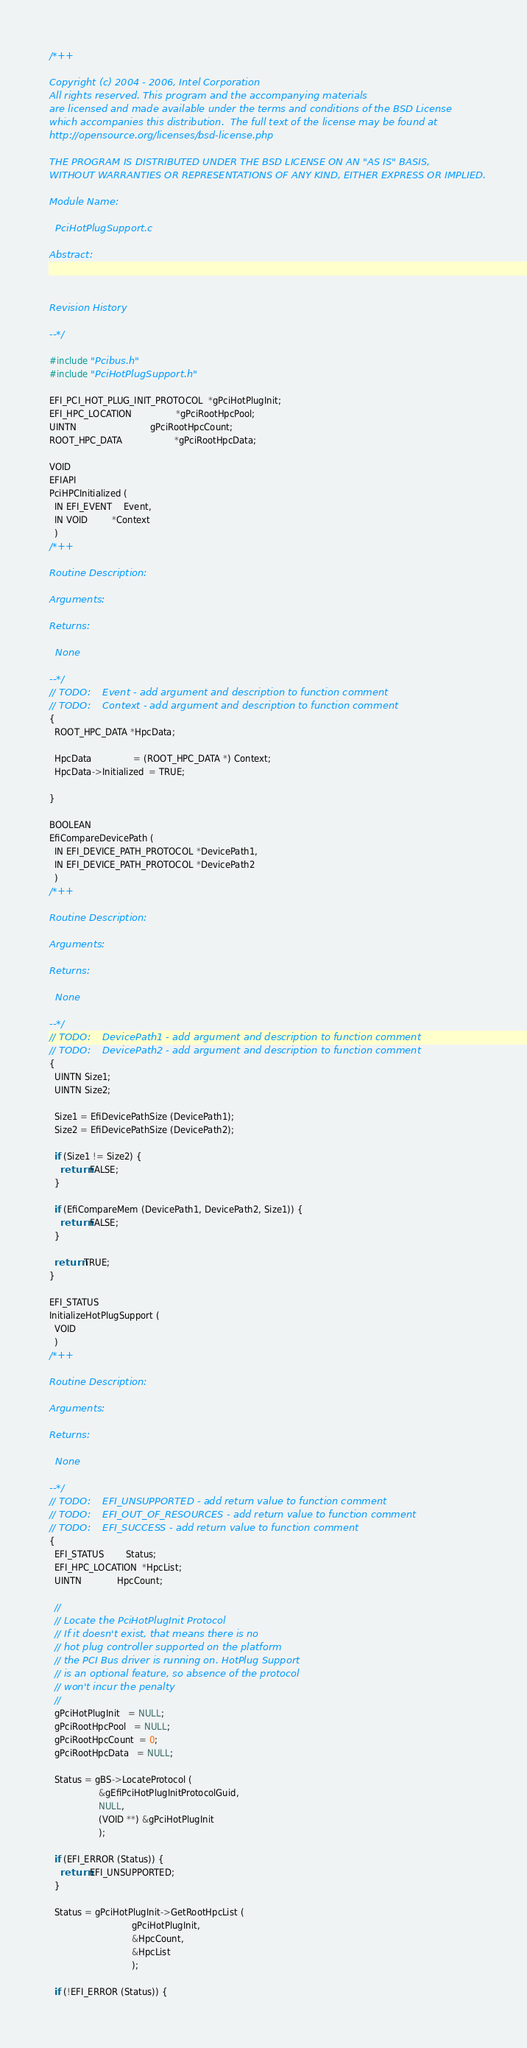Convert code to text. <code><loc_0><loc_0><loc_500><loc_500><_C_>/*++

Copyright (c) 2004 - 2006, Intel Corporation                                                         
All rights reserved. This program and the accompanying materials                          
are licensed and made available under the terms and conditions of the BSD License         
which accompanies this distribution.  The full text of the license may be found at        
http://opensource.org/licenses/bsd-license.php                                            
                                                                                          
THE PROGRAM IS DISTRIBUTED UNDER THE BSD LICENSE ON AN "AS IS" BASIS,                     
WITHOUT WARRANTIES OR REPRESENTATIONS OF ANY KIND, EITHER EXPRESS OR IMPLIED.             

Module Name:

  PciHotPlugSupport.c
  
Abstract:

  

Revision History

--*/

#include "Pcibus.h"
#include "PciHotPlugSupport.h"

EFI_PCI_HOT_PLUG_INIT_PROTOCOL  *gPciHotPlugInit;
EFI_HPC_LOCATION                *gPciRootHpcPool;
UINTN                           gPciRootHpcCount;
ROOT_HPC_DATA                   *gPciRootHpcData;

VOID
EFIAPI
PciHPCInitialized (
  IN EFI_EVENT    Event,
  IN VOID         *Context
  )
/*++

Routine Description:

Arguments:

Returns:

  None

--*/
// TODO:    Event - add argument and description to function comment
// TODO:    Context - add argument and description to function comment
{
  ROOT_HPC_DATA *HpcData;

  HpcData               = (ROOT_HPC_DATA *) Context;
  HpcData->Initialized  = TRUE;

}

BOOLEAN
EfiCompareDevicePath (
  IN EFI_DEVICE_PATH_PROTOCOL *DevicePath1,
  IN EFI_DEVICE_PATH_PROTOCOL *DevicePath2
  )
/*++

Routine Description:

Arguments:

Returns:

  None

--*/
// TODO:    DevicePath1 - add argument and description to function comment
// TODO:    DevicePath2 - add argument and description to function comment
{
  UINTN Size1;
  UINTN Size2;

  Size1 = EfiDevicePathSize (DevicePath1);
  Size2 = EfiDevicePathSize (DevicePath2);

  if (Size1 != Size2) {
    return FALSE;
  }

  if (EfiCompareMem (DevicePath1, DevicePath2, Size1)) {
    return FALSE;
  }

  return TRUE;
}

EFI_STATUS
InitializeHotPlugSupport (
  VOID
  )
/*++

Routine Description:

Arguments:

Returns:

  None

--*/
// TODO:    EFI_UNSUPPORTED - add return value to function comment
// TODO:    EFI_OUT_OF_RESOURCES - add return value to function comment
// TODO:    EFI_SUCCESS - add return value to function comment
{
  EFI_STATUS        Status;
  EFI_HPC_LOCATION  *HpcList;
  UINTN             HpcCount;

  //
  // Locate the PciHotPlugInit Protocol
  // If it doesn't exist, that means there is no
  // hot plug controller supported on the platform
  // the PCI Bus driver is running on. HotPlug Support
  // is an optional feature, so absence of the protocol
  // won't incur the penalty
  //
  gPciHotPlugInit   = NULL;
  gPciRootHpcPool   = NULL;
  gPciRootHpcCount  = 0;
  gPciRootHpcData   = NULL;

  Status = gBS->LocateProtocol (
                  &gEfiPciHotPlugInitProtocolGuid,
                  NULL,
                  (VOID **) &gPciHotPlugInit
                  );

  if (EFI_ERROR (Status)) {
    return EFI_UNSUPPORTED;
  }

  Status = gPciHotPlugInit->GetRootHpcList (
                              gPciHotPlugInit,
                              &HpcCount,
                              &HpcList
                              );

  if (!EFI_ERROR (Status)) {
</code> 